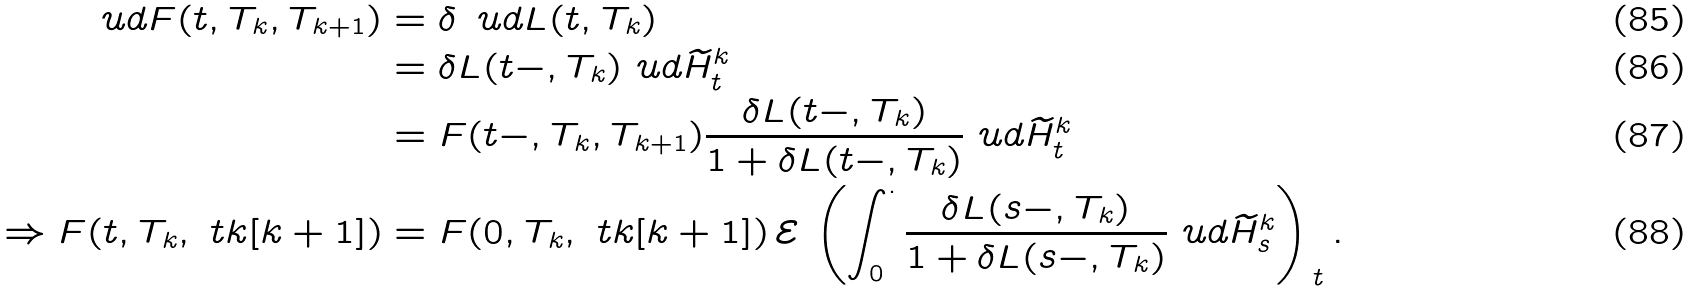Convert formula to latex. <formula><loc_0><loc_0><loc_500><loc_500>\ u d F ( t , T _ { k } , T _ { k + 1 } ) & = \delta \, \ u d L ( t , T _ { k } ) \\ & = \delta L ( t - , T _ { k } ) \ u d \widetilde { H } _ { t } ^ { k } \\ & = F ( t - , T _ { k } , T _ { k + 1 } ) \frac { \delta L ( t - , T _ { k } ) } { 1 + \delta L ( t - , T _ { k } ) } \ u d \widetilde { H } _ { t } ^ { k } \\ \Rightarrow F ( t , T _ { k } , \ t k [ k + 1 ] ) & = F ( 0 , T _ { k } , \ t k [ k + 1 ] ) \, \mathcal { E } \, \left ( \int _ { 0 } ^ { \cdot } \frac { \delta L ( s - , T _ { k } ) } { 1 + \delta L ( s - , T _ { k } ) } \ u d \widetilde { H } _ { s } ^ { k } \right ) _ { \, t } .</formula> 